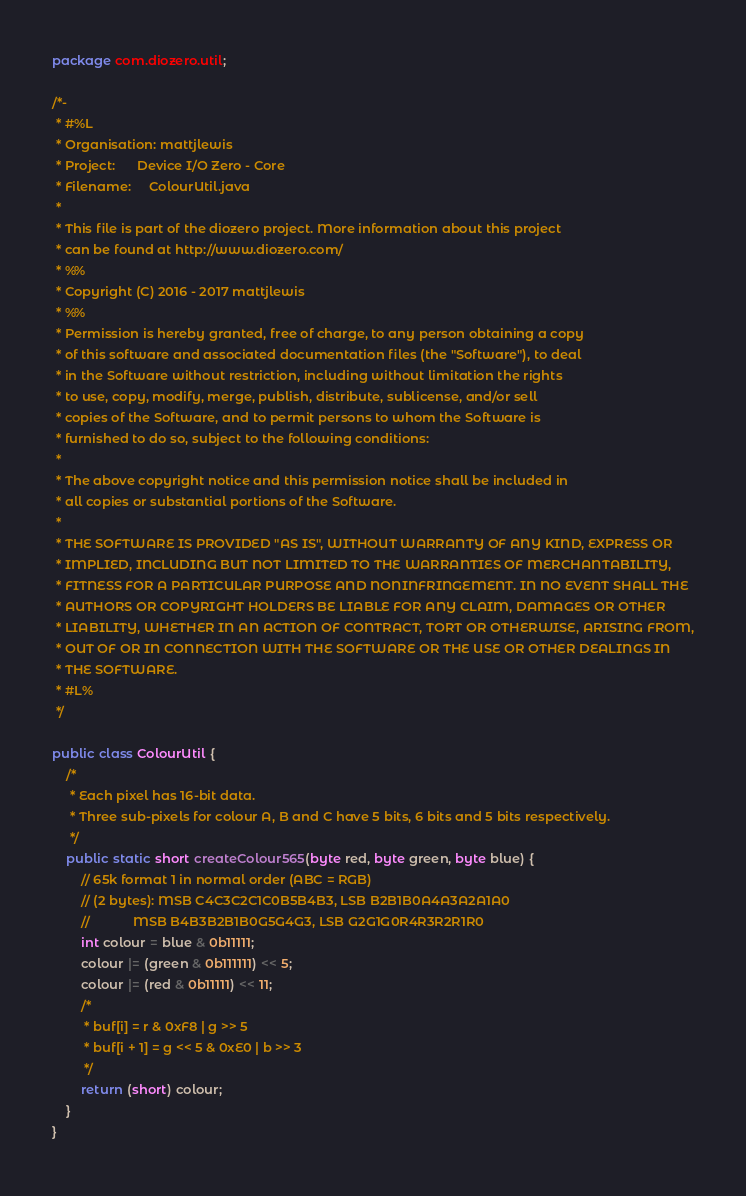<code> <loc_0><loc_0><loc_500><loc_500><_Java_>package com.diozero.util;

/*-
 * #%L
 * Organisation: mattjlewis
 * Project:      Device I/O Zero - Core
 * Filename:     ColourUtil.java  
 * 
 * This file is part of the diozero project. More information about this project
 * can be found at http://www.diozero.com/
 * %%
 * Copyright (C) 2016 - 2017 mattjlewis
 * %%
 * Permission is hereby granted, free of charge, to any person obtaining a copy
 * of this software and associated documentation files (the "Software"), to deal
 * in the Software without restriction, including without limitation the rights
 * to use, copy, modify, merge, publish, distribute, sublicense, and/or sell
 * copies of the Software, and to permit persons to whom the Software is
 * furnished to do so, subject to the following conditions:
 * 
 * The above copyright notice and this permission notice shall be included in
 * all copies or substantial portions of the Software.
 * 
 * THE SOFTWARE IS PROVIDED "AS IS", WITHOUT WARRANTY OF ANY KIND, EXPRESS OR
 * IMPLIED, INCLUDING BUT NOT LIMITED TO THE WARRANTIES OF MERCHANTABILITY,
 * FITNESS FOR A PARTICULAR PURPOSE AND NONINFRINGEMENT. IN NO EVENT SHALL THE
 * AUTHORS OR COPYRIGHT HOLDERS BE LIABLE FOR ANY CLAIM, DAMAGES OR OTHER
 * LIABILITY, WHETHER IN AN ACTION OF CONTRACT, TORT OR OTHERWISE, ARISING FROM,
 * OUT OF OR IN CONNECTION WITH THE SOFTWARE OR THE USE OR OTHER DEALINGS IN
 * THE SOFTWARE.
 * #L%
 */

public class ColourUtil {
	/*
	 * Each pixel has 16-bit data.
	 * Three sub-pixels for colour A, B and C have 5 bits, 6 bits and 5 bits respectively.
	 */
	public static short createColour565(byte red, byte green, byte blue) {
		// 65k format 1 in normal order (ABC = RGB)
		// (2 bytes): MSB C4C3C2C1C0B5B4B3, LSB B2B1B0A4A3A2A1A0
		//            MSB B4B3B2B1B0G5G4G3, LSB G2G1G0R4R3R2R1R0
		int colour = blue & 0b11111;
		colour |= (green & 0b111111) << 5;
		colour |= (red & 0b11111) << 11;
		/*
		 * buf[i] = r & 0xF8 | g >> 5
		 * buf[i + 1] = g << 5 & 0xE0 | b >> 3
		 */
		return (short) colour;
	}
}
</code> 